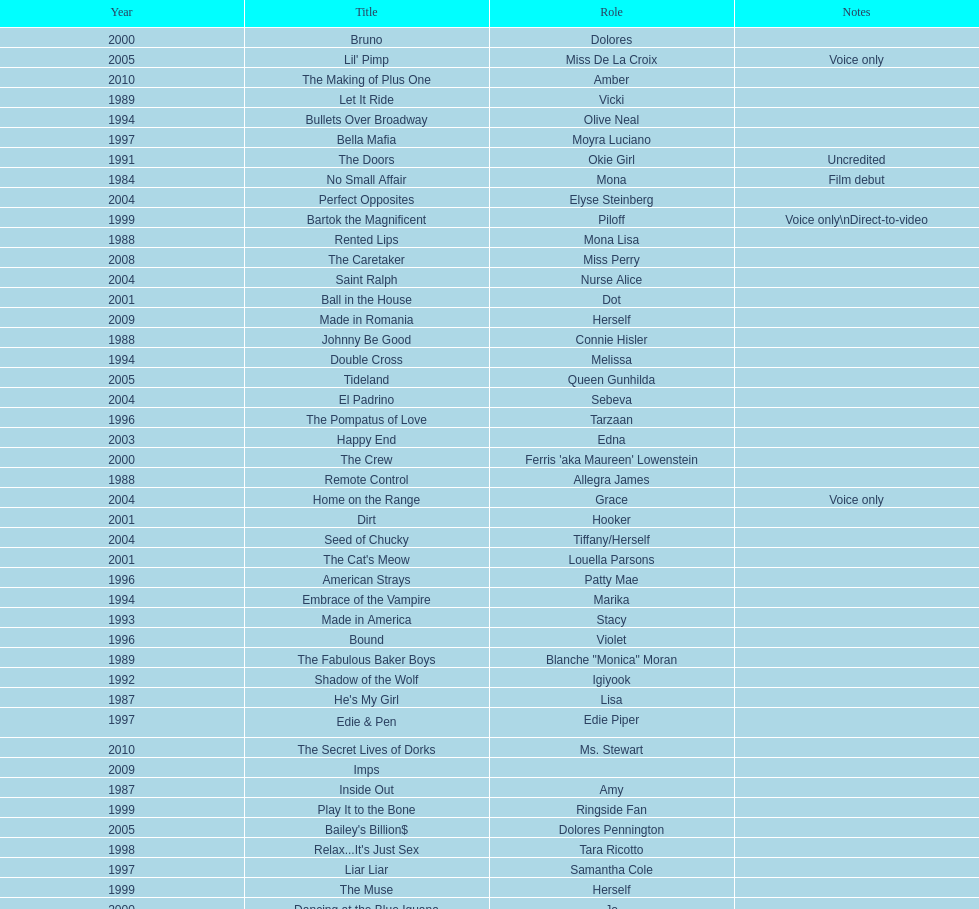How many rolls did jennifer tilly play in the 1980s? 11. 